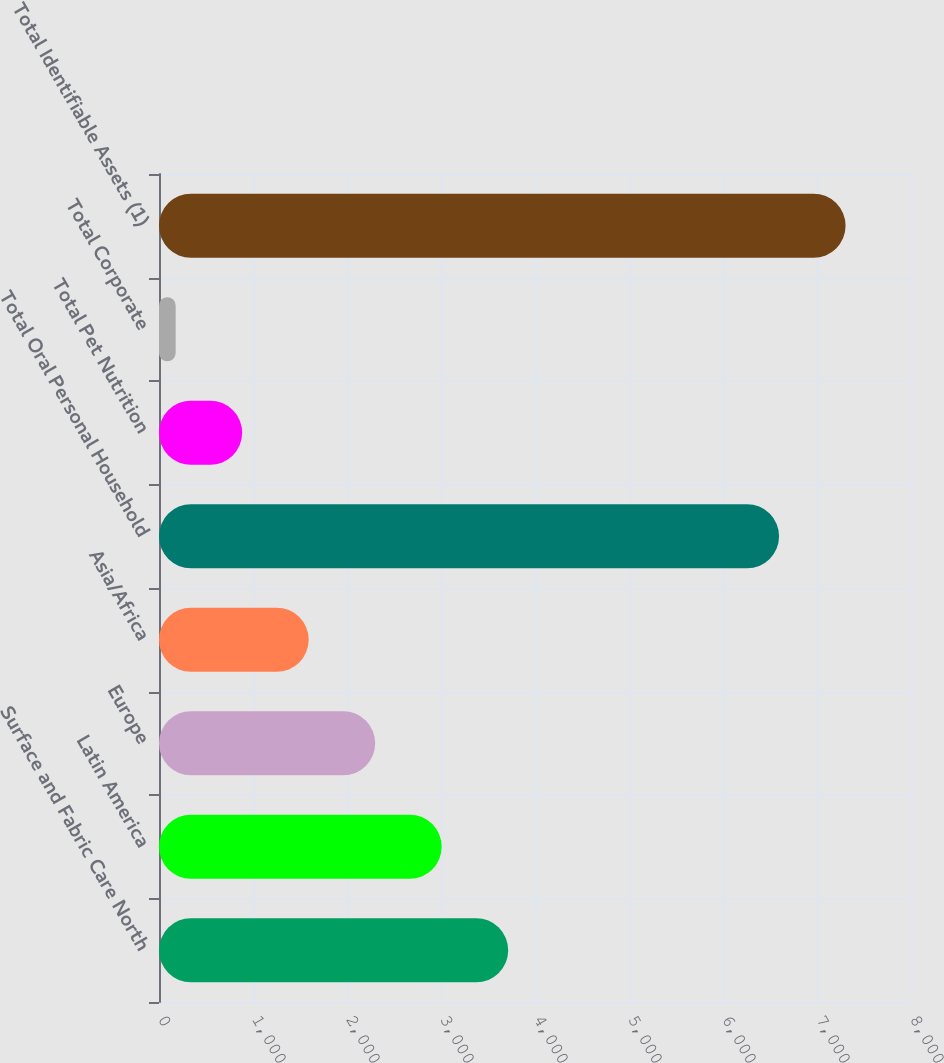Convert chart to OTSL. <chart><loc_0><loc_0><loc_500><loc_500><bar_chart><fcel>Surface and Fabric Care North<fcel>Latin America<fcel>Europe<fcel>Asia/Africa<fcel>Total Oral Personal Household<fcel>Total Pet Nutrition<fcel>Total Corporate<fcel>Total Identifiable Assets (1)<nl><fcel>3714.8<fcel>3007.3<fcel>2299.8<fcel>1592.3<fcel>6596.5<fcel>884.8<fcel>177.3<fcel>7304<nl></chart> 